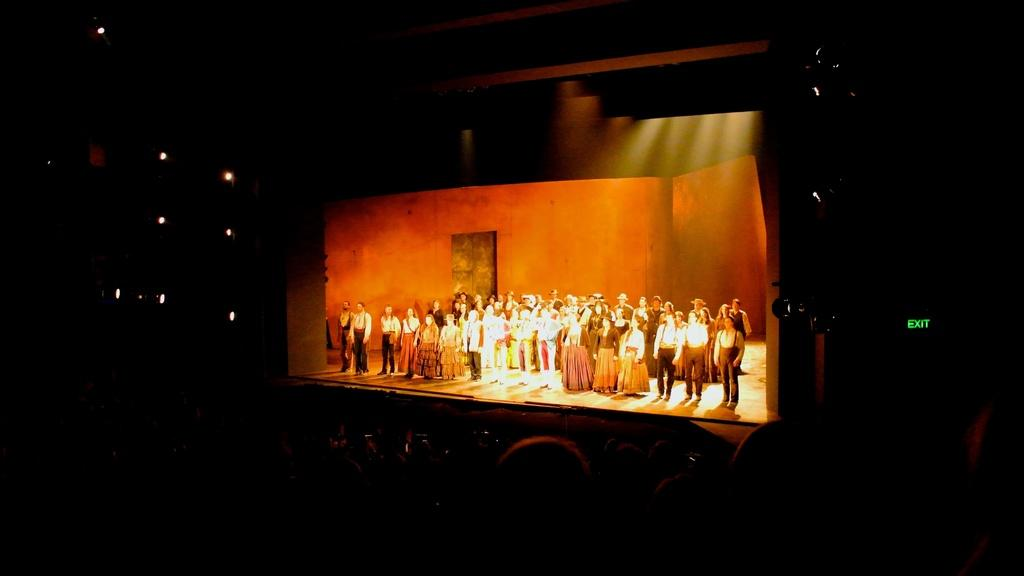What is the main feature in the center of the image? There is a stage in the center of the image. What are the people on the stage wearing? People wearing ancient clothes are on the stage. Can you describe the people at the bottom of the image? There are people at the bottom of the image. What can be seen towards the left side of the image? There are lights towards the left side of the image. What type of art is being displayed on the zipper of the person on the stage? There is no mention of a zipper or any art on a zipper in the image. 